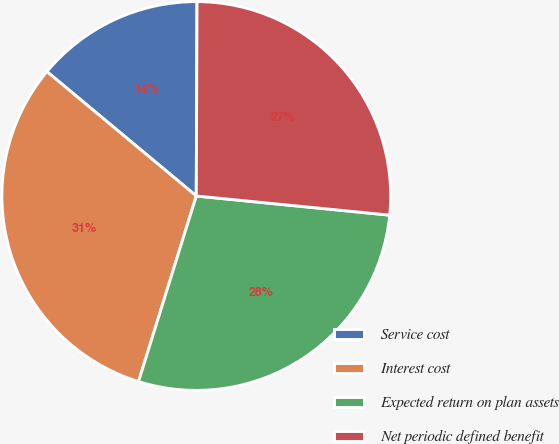Convert chart to OTSL. <chart><loc_0><loc_0><loc_500><loc_500><pie_chart><fcel>Service cost<fcel>Interest cost<fcel>Expected return on plan assets<fcel>Net periodic defined benefit<nl><fcel>14.01%<fcel>31.25%<fcel>28.23%<fcel>26.51%<nl></chart> 